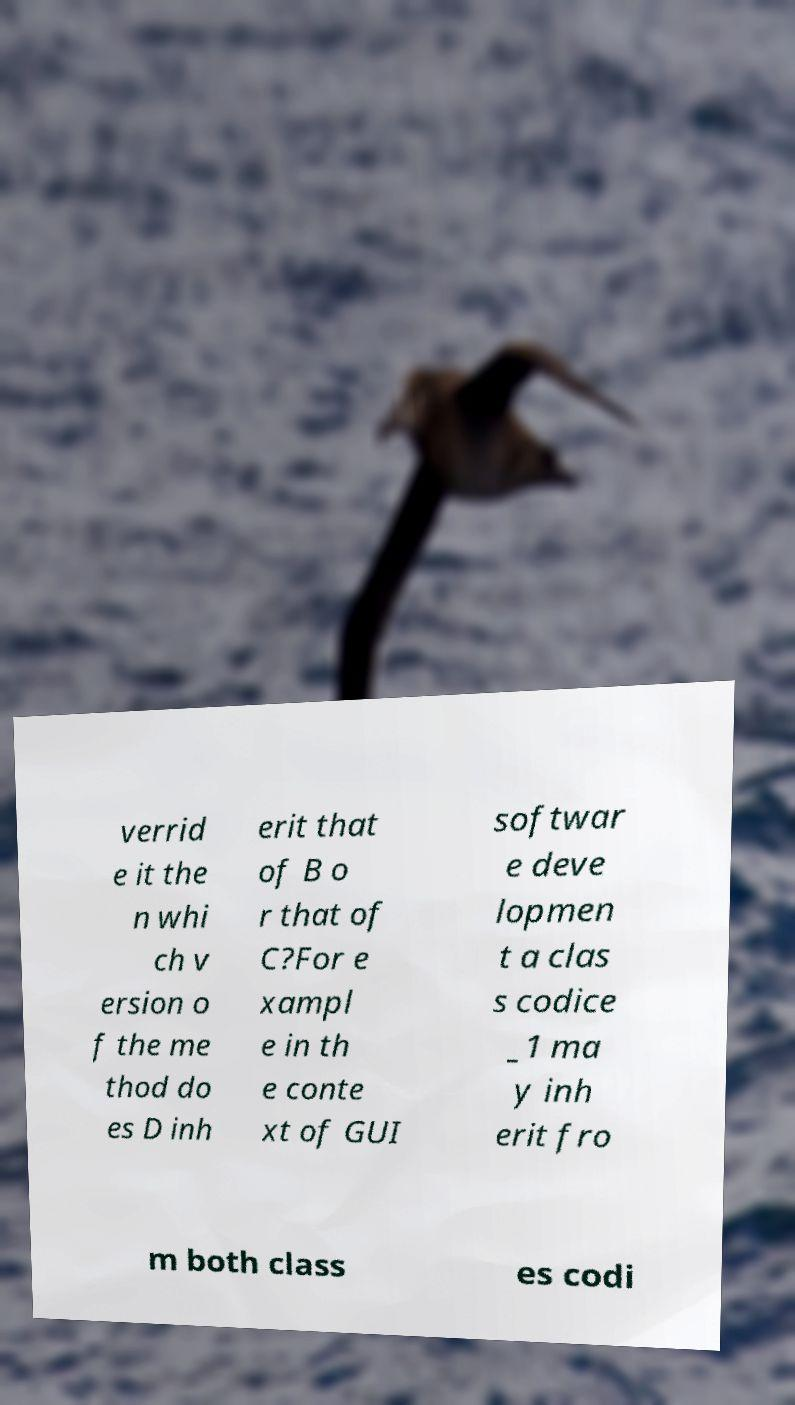What messages or text are displayed in this image? I need them in a readable, typed format. verrid e it the n whi ch v ersion o f the me thod do es D inh erit that of B o r that of C?For e xampl e in th e conte xt of GUI softwar e deve lopmen t a clas s codice _1 ma y inh erit fro m both class es codi 